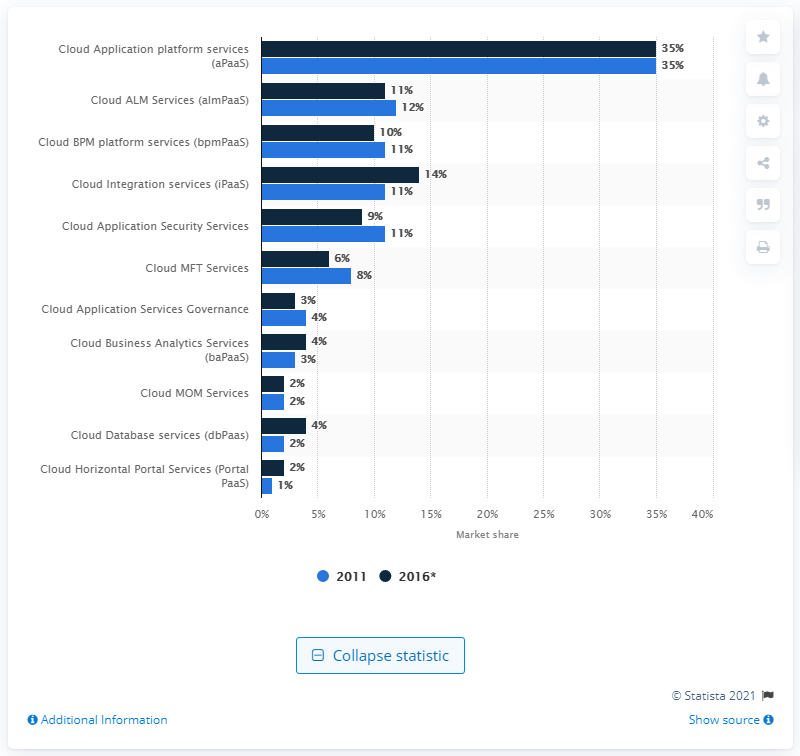List a handful of essential elements in this visual. By the year 2016, almPaaS is expected to account for a significant percentage of the market. The market share of PaaS systems was first measured in 2011. 